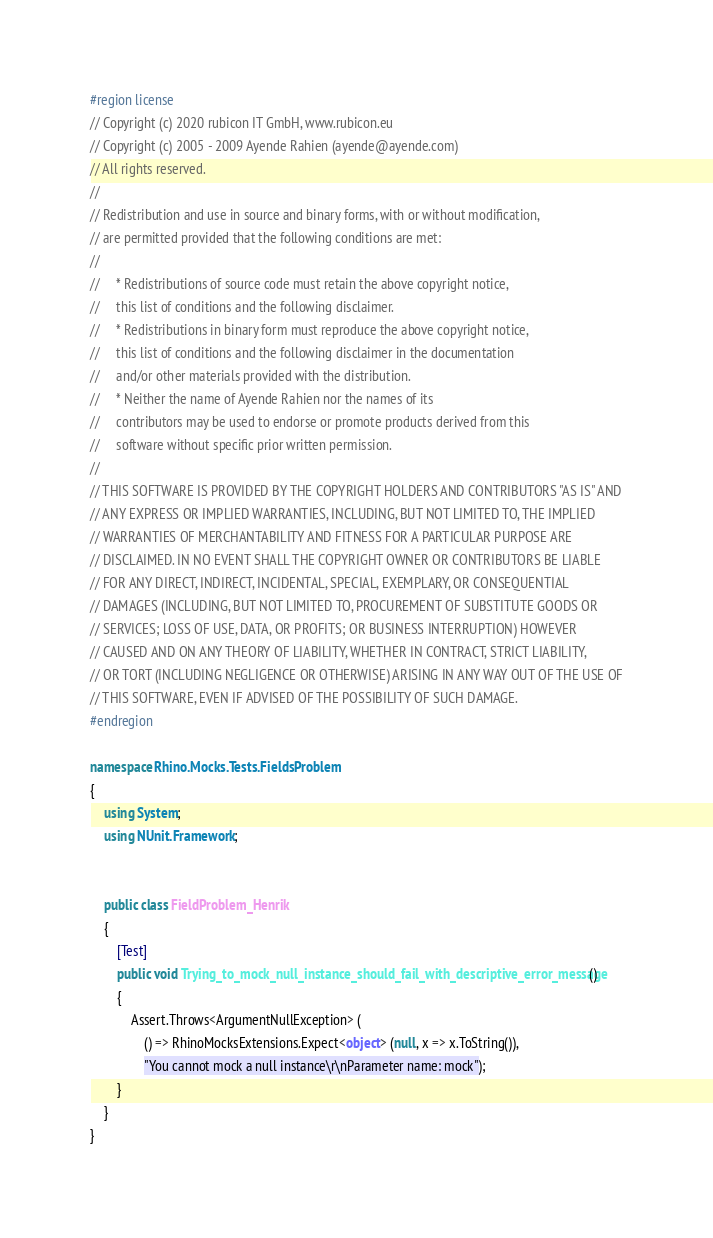<code> <loc_0><loc_0><loc_500><loc_500><_C#_>#region license
// Copyright (c) 2020 rubicon IT GmbH, www.rubicon.eu
// Copyright (c) 2005 - 2009 Ayende Rahien (ayende@ayende.com)
// All rights reserved.
// 
// Redistribution and use in source and binary forms, with or without modification,
// are permitted provided that the following conditions are met:
// 
//     * Redistributions of source code must retain the above copyright notice,
//     this list of conditions and the following disclaimer.
//     * Redistributions in binary form must reproduce the above copyright notice,
//     this list of conditions and the following disclaimer in the documentation
//     and/or other materials provided with the distribution.
//     * Neither the name of Ayende Rahien nor the names of its
//     contributors may be used to endorse or promote products derived from this
//     software without specific prior written permission.
// 
// THIS SOFTWARE IS PROVIDED BY THE COPYRIGHT HOLDERS AND CONTRIBUTORS "AS IS" AND
// ANY EXPRESS OR IMPLIED WARRANTIES, INCLUDING, BUT NOT LIMITED TO, THE IMPLIED
// WARRANTIES OF MERCHANTABILITY AND FITNESS FOR A PARTICULAR PURPOSE ARE
// DISCLAIMED. IN NO EVENT SHALL THE COPYRIGHT OWNER OR CONTRIBUTORS BE LIABLE
// FOR ANY DIRECT, INDIRECT, INCIDENTAL, SPECIAL, EXEMPLARY, OR CONSEQUENTIAL
// DAMAGES (INCLUDING, BUT NOT LIMITED TO, PROCUREMENT OF SUBSTITUTE GOODS OR
// SERVICES; LOSS OF USE, DATA, OR PROFITS; OR BUSINESS INTERRUPTION) HOWEVER
// CAUSED AND ON ANY THEORY OF LIABILITY, WHETHER IN CONTRACT, STRICT LIABILITY,
// OR TORT (INCLUDING NEGLIGENCE OR OTHERWISE) ARISING IN ANY WAY OUT OF THE USE OF
// THIS SOFTWARE, EVEN IF ADVISED OF THE POSSIBILITY OF SUCH DAMAGE.
#endregion

namespace Rhino.Mocks.Tests.FieldsProblem
{
	using System;
	using NUnit.Framework;

	
	public class FieldProblem_Henrik
	{
		[Test]
		public void Trying_to_mock_null_instance_should_fail_with_descriptive_error_message()
		{
            Assert.Throws<ArgumentNullException> (
                () => RhinoMocksExtensions.Expect<object> (null, x => x.ToString()),
                "You cannot mock a null instance\r\nParameter name: mock");
		}
	}
}
</code> 